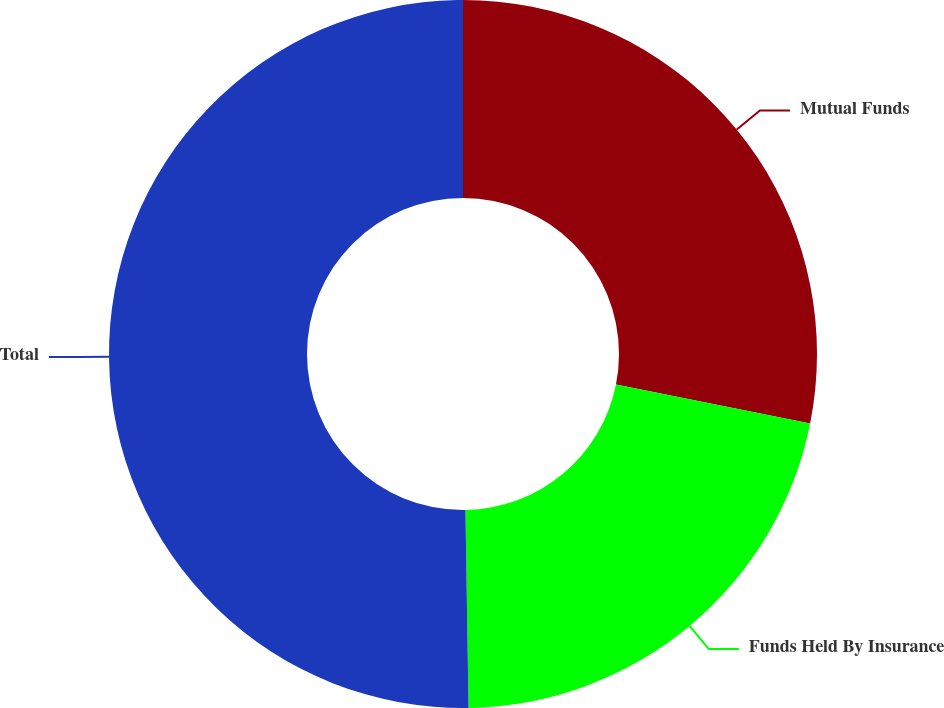Convert chart to OTSL. <chart><loc_0><loc_0><loc_500><loc_500><pie_chart><fcel>Mutual Funds<fcel>Funds Held By Insurance<fcel>Total<nl><fcel>28.14%<fcel>21.61%<fcel>50.25%<nl></chart> 